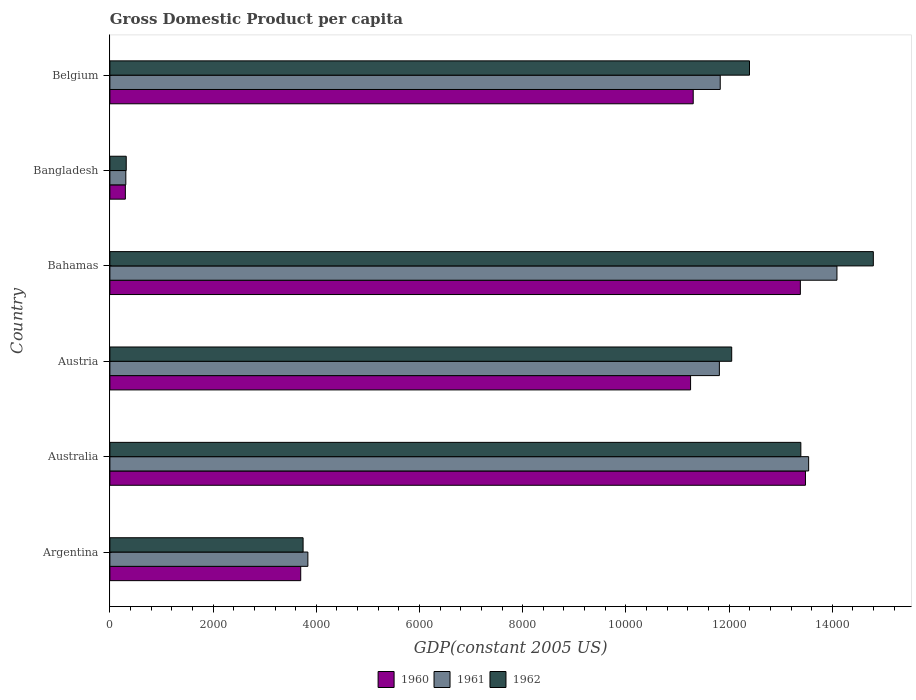How many different coloured bars are there?
Provide a short and direct response. 3. How many groups of bars are there?
Offer a very short reply. 6. Are the number of bars per tick equal to the number of legend labels?
Offer a terse response. Yes. Are the number of bars on each tick of the Y-axis equal?
Make the answer very short. Yes. How many bars are there on the 4th tick from the top?
Give a very brief answer. 3. How many bars are there on the 4th tick from the bottom?
Offer a terse response. 3. What is the GDP per capita in 1961 in Australia?
Ensure brevity in your answer.  1.35e+04. Across all countries, what is the maximum GDP per capita in 1960?
Give a very brief answer. 1.35e+04. Across all countries, what is the minimum GDP per capita in 1960?
Provide a succinct answer. 299.73. In which country was the GDP per capita in 1961 maximum?
Ensure brevity in your answer.  Bahamas. In which country was the GDP per capita in 1961 minimum?
Keep it short and to the point. Bangladesh. What is the total GDP per capita in 1962 in the graph?
Your answer should be very brief. 5.67e+04. What is the difference between the GDP per capita in 1960 in Argentina and that in Belgium?
Give a very brief answer. -7606.57. What is the difference between the GDP per capita in 1962 in Bahamas and the GDP per capita in 1961 in Australia?
Your response must be concise. 1253.39. What is the average GDP per capita in 1961 per country?
Offer a very short reply. 9236.17. What is the difference between the GDP per capita in 1961 and GDP per capita in 1960 in Bahamas?
Your answer should be compact. 709.25. What is the ratio of the GDP per capita in 1961 in Argentina to that in Bahamas?
Ensure brevity in your answer.  0.27. What is the difference between the highest and the second highest GDP per capita in 1961?
Your response must be concise. 548.67. What is the difference between the highest and the lowest GDP per capita in 1962?
Provide a short and direct response. 1.45e+04. In how many countries, is the GDP per capita in 1960 greater than the average GDP per capita in 1960 taken over all countries?
Provide a short and direct response. 4. What does the 3rd bar from the top in Australia represents?
Make the answer very short. 1960. What does the 2nd bar from the bottom in Argentina represents?
Ensure brevity in your answer.  1961. How many bars are there?
Keep it short and to the point. 18. How many countries are there in the graph?
Offer a terse response. 6. Are the values on the major ticks of X-axis written in scientific E-notation?
Give a very brief answer. No. How many legend labels are there?
Provide a succinct answer. 3. How are the legend labels stacked?
Offer a terse response. Horizontal. What is the title of the graph?
Your answer should be compact. Gross Domestic Product per capita. Does "1997" appear as one of the legend labels in the graph?
Make the answer very short. No. What is the label or title of the X-axis?
Your answer should be compact. GDP(constant 2005 US). What is the label or title of the Y-axis?
Make the answer very short. Country. What is the GDP(constant 2005 US) of 1960 in Argentina?
Your response must be concise. 3698.16. What is the GDP(constant 2005 US) in 1961 in Argentina?
Your answer should be compact. 3836.74. What is the GDP(constant 2005 US) in 1962 in Argentina?
Keep it short and to the point. 3744.25. What is the GDP(constant 2005 US) in 1960 in Australia?
Your answer should be very brief. 1.35e+04. What is the GDP(constant 2005 US) in 1961 in Australia?
Keep it short and to the point. 1.35e+04. What is the GDP(constant 2005 US) in 1962 in Australia?
Your response must be concise. 1.34e+04. What is the GDP(constant 2005 US) in 1960 in Austria?
Your response must be concise. 1.13e+04. What is the GDP(constant 2005 US) of 1961 in Austria?
Ensure brevity in your answer.  1.18e+04. What is the GDP(constant 2005 US) of 1962 in Austria?
Give a very brief answer. 1.21e+04. What is the GDP(constant 2005 US) in 1960 in Bahamas?
Your answer should be compact. 1.34e+04. What is the GDP(constant 2005 US) in 1961 in Bahamas?
Your answer should be compact. 1.41e+04. What is the GDP(constant 2005 US) in 1962 in Bahamas?
Your answer should be compact. 1.48e+04. What is the GDP(constant 2005 US) in 1960 in Bangladesh?
Give a very brief answer. 299.73. What is the GDP(constant 2005 US) of 1961 in Bangladesh?
Keep it short and to the point. 308.96. What is the GDP(constant 2005 US) of 1962 in Bangladesh?
Keep it short and to the point. 316.63. What is the GDP(constant 2005 US) of 1960 in Belgium?
Give a very brief answer. 1.13e+04. What is the GDP(constant 2005 US) in 1961 in Belgium?
Provide a short and direct response. 1.18e+04. What is the GDP(constant 2005 US) of 1962 in Belgium?
Your answer should be compact. 1.24e+04. Across all countries, what is the maximum GDP(constant 2005 US) of 1960?
Provide a succinct answer. 1.35e+04. Across all countries, what is the maximum GDP(constant 2005 US) of 1961?
Ensure brevity in your answer.  1.41e+04. Across all countries, what is the maximum GDP(constant 2005 US) in 1962?
Make the answer very short. 1.48e+04. Across all countries, what is the minimum GDP(constant 2005 US) of 1960?
Offer a very short reply. 299.73. Across all countries, what is the minimum GDP(constant 2005 US) of 1961?
Provide a short and direct response. 308.96. Across all countries, what is the minimum GDP(constant 2005 US) in 1962?
Give a very brief answer. 316.63. What is the total GDP(constant 2005 US) in 1960 in the graph?
Make the answer very short. 5.34e+04. What is the total GDP(constant 2005 US) in 1961 in the graph?
Your answer should be compact. 5.54e+04. What is the total GDP(constant 2005 US) in 1962 in the graph?
Ensure brevity in your answer.  5.67e+04. What is the difference between the GDP(constant 2005 US) in 1960 in Argentina and that in Australia?
Your answer should be very brief. -9781.7. What is the difference between the GDP(constant 2005 US) in 1961 in Argentina and that in Australia?
Your answer should be very brief. -9704.74. What is the difference between the GDP(constant 2005 US) in 1962 in Argentina and that in Australia?
Offer a terse response. -9646.16. What is the difference between the GDP(constant 2005 US) of 1960 in Argentina and that in Austria?
Give a very brief answer. -7555.12. What is the difference between the GDP(constant 2005 US) in 1961 in Argentina and that in Austria?
Give a very brief answer. -7974.79. What is the difference between the GDP(constant 2005 US) in 1962 in Argentina and that in Austria?
Your answer should be very brief. -8306.04. What is the difference between the GDP(constant 2005 US) of 1960 in Argentina and that in Bahamas?
Provide a succinct answer. -9682.73. What is the difference between the GDP(constant 2005 US) of 1961 in Argentina and that in Bahamas?
Offer a very short reply. -1.03e+04. What is the difference between the GDP(constant 2005 US) in 1962 in Argentina and that in Bahamas?
Give a very brief answer. -1.11e+04. What is the difference between the GDP(constant 2005 US) of 1960 in Argentina and that in Bangladesh?
Make the answer very short. 3398.43. What is the difference between the GDP(constant 2005 US) in 1961 in Argentina and that in Bangladesh?
Make the answer very short. 3527.78. What is the difference between the GDP(constant 2005 US) of 1962 in Argentina and that in Bangladesh?
Offer a terse response. 3427.62. What is the difference between the GDP(constant 2005 US) in 1960 in Argentina and that in Belgium?
Provide a short and direct response. -7606.57. What is the difference between the GDP(constant 2005 US) in 1961 in Argentina and that in Belgium?
Keep it short and to the point. -7991.43. What is the difference between the GDP(constant 2005 US) of 1962 in Argentina and that in Belgium?
Provide a short and direct response. -8650.96. What is the difference between the GDP(constant 2005 US) of 1960 in Australia and that in Austria?
Offer a very short reply. 2226.58. What is the difference between the GDP(constant 2005 US) in 1961 in Australia and that in Austria?
Offer a very short reply. 1729.95. What is the difference between the GDP(constant 2005 US) in 1962 in Australia and that in Austria?
Give a very brief answer. 1340.12. What is the difference between the GDP(constant 2005 US) in 1960 in Australia and that in Bahamas?
Your answer should be compact. 98.97. What is the difference between the GDP(constant 2005 US) of 1961 in Australia and that in Bahamas?
Offer a very short reply. -548.67. What is the difference between the GDP(constant 2005 US) in 1962 in Australia and that in Bahamas?
Your response must be concise. -1404.45. What is the difference between the GDP(constant 2005 US) of 1960 in Australia and that in Bangladesh?
Ensure brevity in your answer.  1.32e+04. What is the difference between the GDP(constant 2005 US) in 1961 in Australia and that in Bangladesh?
Provide a succinct answer. 1.32e+04. What is the difference between the GDP(constant 2005 US) of 1962 in Australia and that in Bangladesh?
Offer a terse response. 1.31e+04. What is the difference between the GDP(constant 2005 US) of 1960 in Australia and that in Belgium?
Give a very brief answer. 2175.13. What is the difference between the GDP(constant 2005 US) of 1961 in Australia and that in Belgium?
Offer a terse response. 1713.31. What is the difference between the GDP(constant 2005 US) of 1962 in Australia and that in Belgium?
Keep it short and to the point. 995.2. What is the difference between the GDP(constant 2005 US) of 1960 in Austria and that in Bahamas?
Offer a terse response. -2127.61. What is the difference between the GDP(constant 2005 US) of 1961 in Austria and that in Bahamas?
Your answer should be very brief. -2278.61. What is the difference between the GDP(constant 2005 US) in 1962 in Austria and that in Bahamas?
Give a very brief answer. -2744.58. What is the difference between the GDP(constant 2005 US) in 1960 in Austria and that in Bangladesh?
Make the answer very short. 1.10e+04. What is the difference between the GDP(constant 2005 US) of 1961 in Austria and that in Bangladesh?
Your answer should be compact. 1.15e+04. What is the difference between the GDP(constant 2005 US) of 1962 in Austria and that in Bangladesh?
Keep it short and to the point. 1.17e+04. What is the difference between the GDP(constant 2005 US) of 1960 in Austria and that in Belgium?
Keep it short and to the point. -51.45. What is the difference between the GDP(constant 2005 US) of 1961 in Austria and that in Belgium?
Ensure brevity in your answer.  -16.64. What is the difference between the GDP(constant 2005 US) in 1962 in Austria and that in Belgium?
Provide a succinct answer. -344.92. What is the difference between the GDP(constant 2005 US) of 1960 in Bahamas and that in Bangladesh?
Ensure brevity in your answer.  1.31e+04. What is the difference between the GDP(constant 2005 US) in 1961 in Bahamas and that in Bangladesh?
Your answer should be very brief. 1.38e+04. What is the difference between the GDP(constant 2005 US) in 1962 in Bahamas and that in Bangladesh?
Provide a succinct answer. 1.45e+04. What is the difference between the GDP(constant 2005 US) in 1960 in Bahamas and that in Belgium?
Offer a terse response. 2076.16. What is the difference between the GDP(constant 2005 US) of 1961 in Bahamas and that in Belgium?
Keep it short and to the point. 2261.97. What is the difference between the GDP(constant 2005 US) in 1962 in Bahamas and that in Belgium?
Provide a short and direct response. 2399.66. What is the difference between the GDP(constant 2005 US) of 1960 in Bangladesh and that in Belgium?
Ensure brevity in your answer.  -1.10e+04. What is the difference between the GDP(constant 2005 US) of 1961 in Bangladesh and that in Belgium?
Provide a succinct answer. -1.15e+04. What is the difference between the GDP(constant 2005 US) in 1962 in Bangladesh and that in Belgium?
Ensure brevity in your answer.  -1.21e+04. What is the difference between the GDP(constant 2005 US) in 1960 in Argentina and the GDP(constant 2005 US) in 1961 in Australia?
Offer a terse response. -9843.32. What is the difference between the GDP(constant 2005 US) in 1960 in Argentina and the GDP(constant 2005 US) in 1962 in Australia?
Keep it short and to the point. -9692.26. What is the difference between the GDP(constant 2005 US) of 1961 in Argentina and the GDP(constant 2005 US) of 1962 in Australia?
Make the answer very short. -9553.68. What is the difference between the GDP(constant 2005 US) in 1960 in Argentina and the GDP(constant 2005 US) in 1961 in Austria?
Give a very brief answer. -8113.37. What is the difference between the GDP(constant 2005 US) of 1960 in Argentina and the GDP(constant 2005 US) of 1962 in Austria?
Ensure brevity in your answer.  -8352.13. What is the difference between the GDP(constant 2005 US) of 1961 in Argentina and the GDP(constant 2005 US) of 1962 in Austria?
Give a very brief answer. -8213.56. What is the difference between the GDP(constant 2005 US) of 1960 in Argentina and the GDP(constant 2005 US) of 1961 in Bahamas?
Provide a succinct answer. -1.04e+04. What is the difference between the GDP(constant 2005 US) in 1960 in Argentina and the GDP(constant 2005 US) in 1962 in Bahamas?
Your answer should be very brief. -1.11e+04. What is the difference between the GDP(constant 2005 US) in 1961 in Argentina and the GDP(constant 2005 US) in 1962 in Bahamas?
Make the answer very short. -1.10e+04. What is the difference between the GDP(constant 2005 US) in 1960 in Argentina and the GDP(constant 2005 US) in 1961 in Bangladesh?
Offer a very short reply. 3389.2. What is the difference between the GDP(constant 2005 US) of 1960 in Argentina and the GDP(constant 2005 US) of 1962 in Bangladesh?
Your answer should be very brief. 3381.53. What is the difference between the GDP(constant 2005 US) in 1961 in Argentina and the GDP(constant 2005 US) in 1962 in Bangladesh?
Your response must be concise. 3520.11. What is the difference between the GDP(constant 2005 US) in 1960 in Argentina and the GDP(constant 2005 US) in 1961 in Belgium?
Offer a terse response. -8130.01. What is the difference between the GDP(constant 2005 US) in 1960 in Argentina and the GDP(constant 2005 US) in 1962 in Belgium?
Offer a very short reply. -8697.05. What is the difference between the GDP(constant 2005 US) in 1961 in Argentina and the GDP(constant 2005 US) in 1962 in Belgium?
Give a very brief answer. -8558.47. What is the difference between the GDP(constant 2005 US) of 1960 in Australia and the GDP(constant 2005 US) of 1961 in Austria?
Your answer should be compact. 1668.34. What is the difference between the GDP(constant 2005 US) of 1960 in Australia and the GDP(constant 2005 US) of 1962 in Austria?
Give a very brief answer. 1429.57. What is the difference between the GDP(constant 2005 US) of 1961 in Australia and the GDP(constant 2005 US) of 1962 in Austria?
Keep it short and to the point. 1491.18. What is the difference between the GDP(constant 2005 US) in 1960 in Australia and the GDP(constant 2005 US) in 1961 in Bahamas?
Provide a short and direct response. -610.28. What is the difference between the GDP(constant 2005 US) in 1960 in Australia and the GDP(constant 2005 US) in 1962 in Bahamas?
Your answer should be very brief. -1315.01. What is the difference between the GDP(constant 2005 US) in 1961 in Australia and the GDP(constant 2005 US) in 1962 in Bahamas?
Make the answer very short. -1253.39. What is the difference between the GDP(constant 2005 US) of 1960 in Australia and the GDP(constant 2005 US) of 1961 in Bangladesh?
Your response must be concise. 1.32e+04. What is the difference between the GDP(constant 2005 US) in 1960 in Australia and the GDP(constant 2005 US) in 1962 in Bangladesh?
Provide a succinct answer. 1.32e+04. What is the difference between the GDP(constant 2005 US) of 1961 in Australia and the GDP(constant 2005 US) of 1962 in Bangladesh?
Keep it short and to the point. 1.32e+04. What is the difference between the GDP(constant 2005 US) in 1960 in Australia and the GDP(constant 2005 US) in 1961 in Belgium?
Make the answer very short. 1651.7. What is the difference between the GDP(constant 2005 US) of 1960 in Australia and the GDP(constant 2005 US) of 1962 in Belgium?
Your answer should be very brief. 1084.65. What is the difference between the GDP(constant 2005 US) of 1961 in Australia and the GDP(constant 2005 US) of 1962 in Belgium?
Offer a terse response. 1146.26. What is the difference between the GDP(constant 2005 US) in 1960 in Austria and the GDP(constant 2005 US) in 1961 in Bahamas?
Your response must be concise. -2836.86. What is the difference between the GDP(constant 2005 US) in 1960 in Austria and the GDP(constant 2005 US) in 1962 in Bahamas?
Your answer should be compact. -3541.59. What is the difference between the GDP(constant 2005 US) in 1961 in Austria and the GDP(constant 2005 US) in 1962 in Bahamas?
Keep it short and to the point. -2983.34. What is the difference between the GDP(constant 2005 US) of 1960 in Austria and the GDP(constant 2005 US) of 1961 in Bangladesh?
Your response must be concise. 1.09e+04. What is the difference between the GDP(constant 2005 US) of 1960 in Austria and the GDP(constant 2005 US) of 1962 in Bangladesh?
Your answer should be compact. 1.09e+04. What is the difference between the GDP(constant 2005 US) in 1961 in Austria and the GDP(constant 2005 US) in 1962 in Bangladesh?
Offer a terse response. 1.15e+04. What is the difference between the GDP(constant 2005 US) of 1960 in Austria and the GDP(constant 2005 US) of 1961 in Belgium?
Provide a succinct answer. -574.88. What is the difference between the GDP(constant 2005 US) in 1960 in Austria and the GDP(constant 2005 US) in 1962 in Belgium?
Your answer should be very brief. -1141.93. What is the difference between the GDP(constant 2005 US) of 1961 in Austria and the GDP(constant 2005 US) of 1962 in Belgium?
Your answer should be compact. -583.69. What is the difference between the GDP(constant 2005 US) of 1960 in Bahamas and the GDP(constant 2005 US) of 1961 in Bangladesh?
Ensure brevity in your answer.  1.31e+04. What is the difference between the GDP(constant 2005 US) of 1960 in Bahamas and the GDP(constant 2005 US) of 1962 in Bangladesh?
Provide a short and direct response. 1.31e+04. What is the difference between the GDP(constant 2005 US) of 1961 in Bahamas and the GDP(constant 2005 US) of 1962 in Bangladesh?
Your answer should be compact. 1.38e+04. What is the difference between the GDP(constant 2005 US) in 1960 in Bahamas and the GDP(constant 2005 US) in 1961 in Belgium?
Keep it short and to the point. 1552.73. What is the difference between the GDP(constant 2005 US) of 1960 in Bahamas and the GDP(constant 2005 US) of 1962 in Belgium?
Your answer should be compact. 985.68. What is the difference between the GDP(constant 2005 US) in 1961 in Bahamas and the GDP(constant 2005 US) in 1962 in Belgium?
Give a very brief answer. 1694.93. What is the difference between the GDP(constant 2005 US) in 1960 in Bangladesh and the GDP(constant 2005 US) in 1961 in Belgium?
Your answer should be very brief. -1.15e+04. What is the difference between the GDP(constant 2005 US) in 1960 in Bangladesh and the GDP(constant 2005 US) in 1962 in Belgium?
Offer a terse response. -1.21e+04. What is the difference between the GDP(constant 2005 US) in 1961 in Bangladesh and the GDP(constant 2005 US) in 1962 in Belgium?
Your answer should be very brief. -1.21e+04. What is the average GDP(constant 2005 US) of 1960 per country?
Your answer should be compact. 8902.77. What is the average GDP(constant 2005 US) of 1961 per country?
Make the answer very short. 9236.17. What is the average GDP(constant 2005 US) of 1962 per country?
Make the answer very short. 9448.61. What is the difference between the GDP(constant 2005 US) in 1960 and GDP(constant 2005 US) in 1961 in Argentina?
Your answer should be very brief. -138.58. What is the difference between the GDP(constant 2005 US) in 1960 and GDP(constant 2005 US) in 1962 in Argentina?
Offer a very short reply. -46.1. What is the difference between the GDP(constant 2005 US) in 1961 and GDP(constant 2005 US) in 1962 in Argentina?
Offer a terse response. 92.48. What is the difference between the GDP(constant 2005 US) in 1960 and GDP(constant 2005 US) in 1961 in Australia?
Provide a succinct answer. -61.61. What is the difference between the GDP(constant 2005 US) of 1960 and GDP(constant 2005 US) of 1962 in Australia?
Keep it short and to the point. 89.45. What is the difference between the GDP(constant 2005 US) in 1961 and GDP(constant 2005 US) in 1962 in Australia?
Your answer should be very brief. 151.06. What is the difference between the GDP(constant 2005 US) of 1960 and GDP(constant 2005 US) of 1961 in Austria?
Provide a short and direct response. -558.24. What is the difference between the GDP(constant 2005 US) in 1960 and GDP(constant 2005 US) in 1962 in Austria?
Ensure brevity in your answer.  -797.01. What is the difference between the GDP(constant 2005 US) of 1961 and GDP(constant 2005 US) of 1962 in Austria?
Your answer should be very brief. -238.77. What is the difference between the GDP(constant 2005 US) of 1960 and GDP(constant 2005 US) of 1961 in Bahamas?
Give a very brief answer. -709.25. What is the difference between the GDP(constant 2005 US) of 1960 and GDP(constant 2005 US) of 1962 in Bahamas?
Offer a terse response. -1413.98. What is the difference between the GDP(constant 2005 US) in 1961 and GDP(constant 2005 US) in 1962 in Bahamas?
Make the answer very short. -704.73. What is the difference between the GDP(constant 2005 US) of 1960 and GDP(constant 2005 US) of 1961 in Bangladesh?
Ensure brevity in your answer.  -9.23. What is the difference between the GDP(constant 2005 US) of 1960 and GDP(constant 2005 US) of 1962 in Bangladesh?
Give a very brief answer. -16.9. What is the difference between the GDP(constant 2005 US) of 1961 and GDP(constant 2005 US) of 1962 in Bangladesh?
Your answer should be very brief. -7.67. What is the difference between the GDP(constant 2005 US) of 1960 and GDP(constant 2005 US) of 1961 in Belgium?
Offer a terse response. -523.44. What is the difference between the GDP(constant 2005 US) in 1960 and GDP(constant 2005 US) in 1962 in Belgium?
Give a very brief answer. -1090.48. What is the difference between the GDP(constant 2005 US) in 1961 and GDP(constant 2005 US) in 1962 in Belgium?
Offer a terse response. -567.05. What is the ratio of the GDP(constant 2005 US) in 1960 in Argentina to that in Australia?
Offer a terse response. 0.27. What is the ratio of the GDP(constant 2005 US) of 1961 in Argentina to that in Australia?
Your response must be concise. 0.28. What is the ratio of the GDP(constant 2005 US) of 1962 in Argentina to that in Australia?
Provide a short and direct response. 0.28. What is the ratio of the GDP(constant 2005 US) of 1960 in Argentina to that in Austria?
Ensure brevity in your answer.  0.33. What is the ratio of the GDP(constant 2005 US) of 1961 in Argentina to that in Austria?
Give a very brief answer. 0.32. What is the ratio of the GDP(constant 2005 US) of 1962 in Argentina to that in Austria?
Your answer should be compact. 0.31. What is the ratio of the GDP(constant 2005 US) of 1960 in Argentina to that in Bahamas?
Ensure brevity in your answer.  0.28. What is the ratio of the GDP(constant 2005 US) in 1961 in Argentina to that in Bahamas?
Ensure brevity in your answer.  0.27. What is the ratio of the GDP(constant 2005 US) of 1962 in Argentina to that in Bahamas?
Keep it short and to the point. 0.25. What is the ratio of the GDP(constant 2005 US) in 1960 in Argentina to that in Bangladesh?
Ensure brevity in your answer.  12.34. What is the ratio of the GDP(constant 2005 US) of 1961 in Argentina to that in Bangladesh?
Make the answer very short. 12.42. What is the ratio of the GDP(constant 2005 US) in 1962 in Argentina to that in Bangladesh?
Offer a terse response. 11.83. What is the ratio of the GDP(constant 2005 US) in 1960 in Argentina to that in Belgium?
Your answer should be very brief. 0.33. What is the ratio of the GDP(constant 2005 US) of 1961 in Argentina to that in Belgium?
Offer a very short reply. 0.32. What is the ratio of the GDP(constant 2005 US) in 1962 in Argentina to that in Belgium?
Provide a short and direct response. 0.3. What is the ratio of the GDP(constant 2005 US) of 1960 in Australia to that in Austria?
Ensure brevity in your answer.  1.2. What is the ratio of the GDP(constant 2005 US) of 1961 in Australia to that in Austria?
Ensure brevity in your answer.  1.15. What is the ratio of the GDP(constant 2005 US) in 1962 in Australia to that in Austria?
Offer a very short reply. 1.11. What is the ratio of the GDP(constant 2005 US) in 1960 in Australia to that in Bahamas?
Make the answer very short. 1.01. What is the ratio of the GDP(constant 2005 US) in 1961 in Australia to that in Bahamas?
Offer a terse response. 0.96. What is the ratio of the GDP(constant 2005 US) of 1962 in Australia to that in Bahamas?
Keep it short and to the point. 0.91. What is the ratio of the GDP(constant 2005 US) of 1960 in Australia to that in Bangladesh?
Ensure brevity in your answer.  44.97. What is the ratio of the GDP(constant 2005 US) of 1961 in Australia to that in Bangladesh?
Your answer should be very brief. 43.83. What is the ratio of the GDP(constant 2005 US) in 1962 in Australia to that in Bangladesh?
Give a very brief answer. 42.29. What is the ratio of the GDP(constant 2005 US) of 1960 in Australia to that in Belgium?
Offer a terse response. 1.19. What is the ratio of the GDP(constant 2005 US) of 1961 in Australia to that in Belgium?
Ensure brevity in your answer.  1.14. What is the ratio of the GDP(constant 2005 US) of 1962 in Australia to that in Belgium?
Make the answer very short. 1.08. What is the ratio of the GDP(constant 2005 US) in 1960 in Austria to that in Bahamas?
Give a very brief answer. 0.84. What is the ratio of the GDP(constant 2005 US) of 1961 in Austria to that in Bahamas?
Keep it short and to the point. 0.84. What is the ratio of the GDP(constant 2005 US) of 1962 in Austria to that in Bahamas?
Make the answer very short. 0.81. What is the ratio of the GDP(constant 2005 US) of 1960 in Austria to that in Bangladesh?
Provide a short and direct response. 37.55. What is the ratio of the GDP(constant 2005 US) of 1961 in Austria to that in Bangladesh?
Keep it short and to the point. 38.23. What is the ratio of the GDP(constant 2005 US) in 1962 in Austria to that in Bangladesh?
Your answer should be compact. 38.06. What is the ratio of the GDP(constant 2005 US) of 1961 in Austria to that in Belgium?
Your response must be concise. 1. What is the ratio of the GDP(constant 2005 US) of 1962 in Austria to that in Belgium?
Provide a short and direct response. 0.97. What is the ratio of the GDP(constant 2005 US) of 1960 in Bahamas to that in Bangladesh?
Provide a short and direct response. 44.64. What is the ratio of the GDP(constant 2005 US) in 1961 in Bahamas to that in Bangladesh?
Make the answer very short. 45.61. What is the ratio of the GDP(constant 2005 US) of 1962 in Bahamas to that in Bangladesh?
Provide a short and direct response. 46.73. What is the ratio of the GDP(constant 2005 US) in 1960 in Bahamas to that in Belgium?
Your response must be concise. 1.18. What is the ratio of the GDP(constant 2005 US) in 1961 in Bahamas to that in Belgium?
Make the answer very short. 1.19. What is the ratio of the GDP(constant 2005 US) in 1962 in Bahamas to that in Belgium?
Your answer should be very brief. 1.19. What is the ratio of the GDP(constant 2005 US) in 1960 in Bangladesh to that in Belgium?
Give a very brief answer. 0.03. What is the ratio of the GDP(constant 2005 US) of 1961 in Bangladesh to that in Belgium?
Make the answer very short. 0.03. What is the ratio of the GDP(constant 2005 US) in 1962 in Bangladesh to that in Belgium?
Your answer should be very brief. 0.03. What is the difference between the highest and the second highest GDP(constant 2005 US) in 1960?
Provide a succinct answer. 98.97. What is the difference between the highest and the second highest GDP(constant 2005 US) of 1961?
Your answer should be compact. 548.67. What is the difference between the highest and the second highest GDP(constant 2005 US) in 1962?
Provide a short and direct response. 1404.45. What is the difference between the highest and the lowest GDP(constant 2005 US) in 1960?
Give a very brief answer. 1.32e+04. What is the difference between the highest and the lowest GDP(constant 2005 US) of 1961?
Give a very brief answer. 1.38e+04. What is the difference between the highest and the lowest GDP(constant 2005 US) in 1962?
Your answer should be compact. 1.45e+04. 